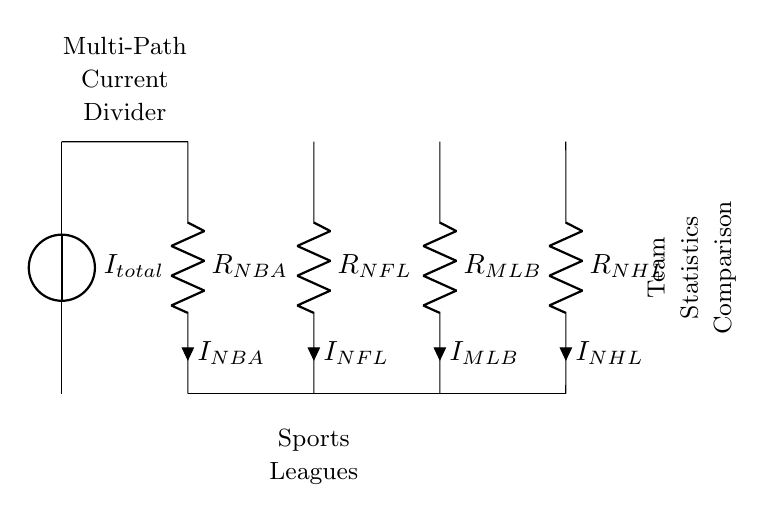What is the total current input to the circuit? The total current input is denoted as I_total, which is the source that splits into multiple branches.
Answer: I_total What are the sports leagues represented in the circuit? The circuit shows four leagues represented as resistors: NBA, NFL, MLB, and NHL.
Answer: NBA, NFL, MLB, NHL Which resistor represents the NFL statistics? The NFL statistics are represented by the resistor labeled R_NFL.
Answer: R_NFL How many paths does the current divide into? The circuit diagram features four paths for current to divide into, one for each sports league represented.
Answer: Four What is the relationship between the resistors in a current divider? In a current divider, the total current is divided among the resistors inversely proportional to their resistance values.
Answer: Inverse relationship What does the current flowing through each resistor represent? The current through each resistor represents the contribution of that particular sports league’s statistics to the total input current.
Answer: Contribution to total statistics What component indicates the purpose of this circuit in the context of sports analysis? The labeled node "Team Statistics Comparison" indicates that the purpose is to compare statistics from different teams across leagues.
Answer: Team Statistics Comparison 